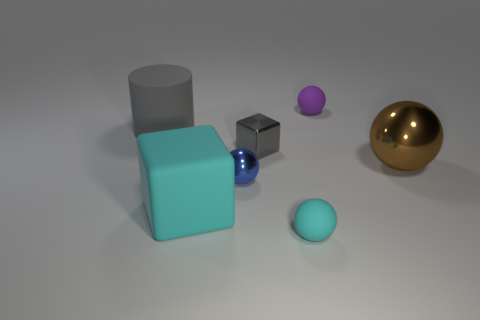Is there anything else of the same color as the large shiny ball?
Offer a very short reply. No. Is the number of big gray matte things less than the number of small blue matte spheres?
Make the answer very short. No. Do the cyan matte thing to the left of the metallic cube and the gray thing on the left side of the tiny blue sphere have the same shape?
Give a very brief answer. No. The large cube is what color?
Your answer should be compact. Cyan. How many rubber objects are either blue balls or cyan objects?
Ensure brevity in your answer.  2. The large shiny object that is the same shape as the tiny cyan object is what color?
Provide a short and direct response. Brown. Are there any big yellow metallic spheres?
Make the answer very short. No. Is the material of the cyan object that is to the left of the blue metal thing the same as the cube that is behind the large cyan rubber thing?
Keep it short and to the point. No. What shape is the small metallic thing that is the same color as the rubber cylinder?
Ensure brevity in your answer.  Cube. How many things are either things that are behind the large brown shiny ball or big things on the left side of the shiny block?
Make the answer very short. 4. 